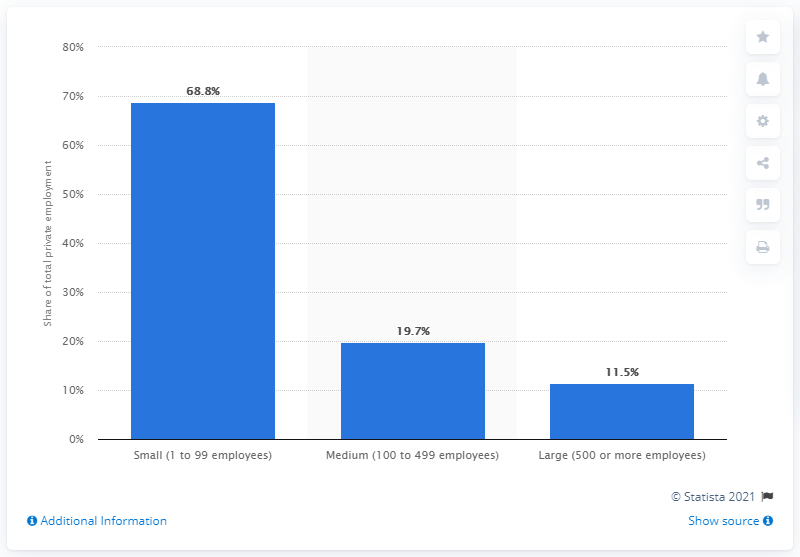Indicate a few pertinent items in this graphic. In 2019, approximately 68.8% of all workers in the private sector were employed by small businesses. 